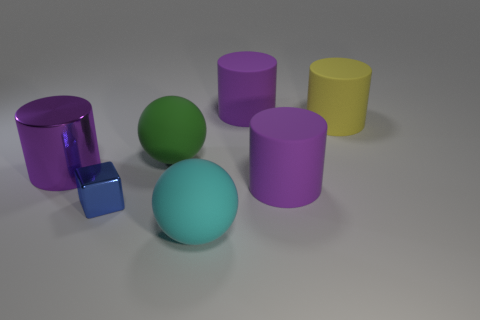How many purple cylinders must be subtracted to get 1 purple cylinders? 2 Subtract all brown cubes. How many purple cylinders are left? 3 Add 2 blue shiny things. How many objects exist? 9 Subtract all cylinders. How many objects are left? 3 Add 2 cyan objects. How many cyan objects exist? 3 Subtract 0 brown cubes. How many objects are left? 7 Subtract all large rubber cylinders. Subtract all yellow objects. How many objects are left? 3 Add 6 large green objects. How many large green objects are left? 7 